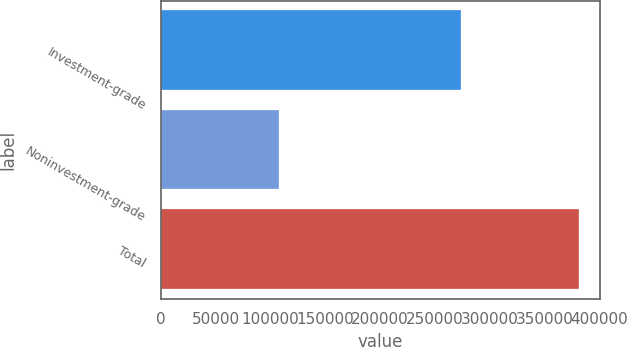<chart> <loc_0><loc_0><loc_500><loc_500><bar_chart><fcel>Investment-grade<fcel>Noninvestment-grade<fcel>Total<nl><fcel>273688<fcel>107955<fcel>381643<nl></chart> 